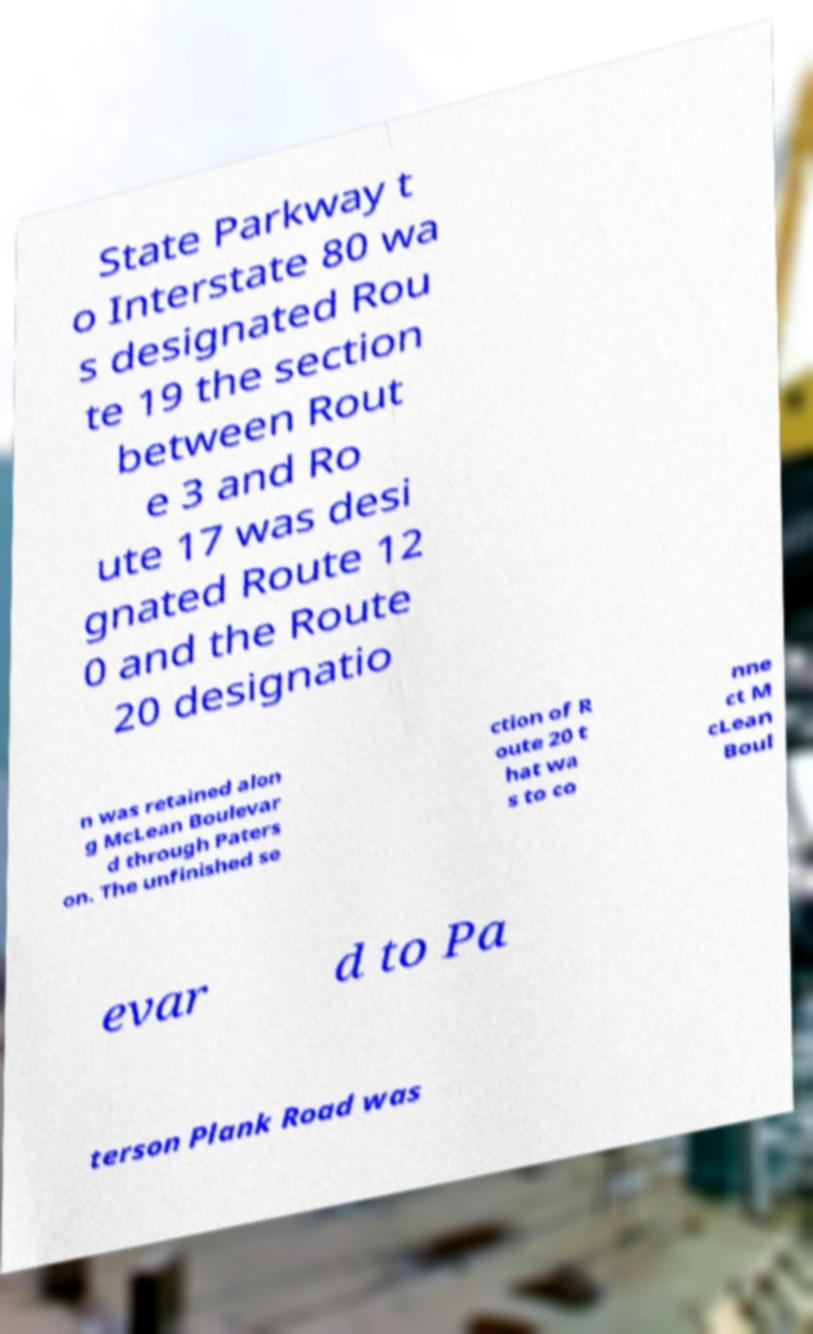Please identify and transcribe the text found in this image. State Parkway t o Interstate 80 wa s designated Rou te 19 the section between Rout e 3 and Ro ute 17 was desi gnated Route 12 0 and the Route 20 designatio n was retained alon g McLean Boulevar d through Paters on. The unfinished se ction of R oute 20 t hat wa s to co nne ct M cLean Boul evar d to Pa terson Plank Road was 